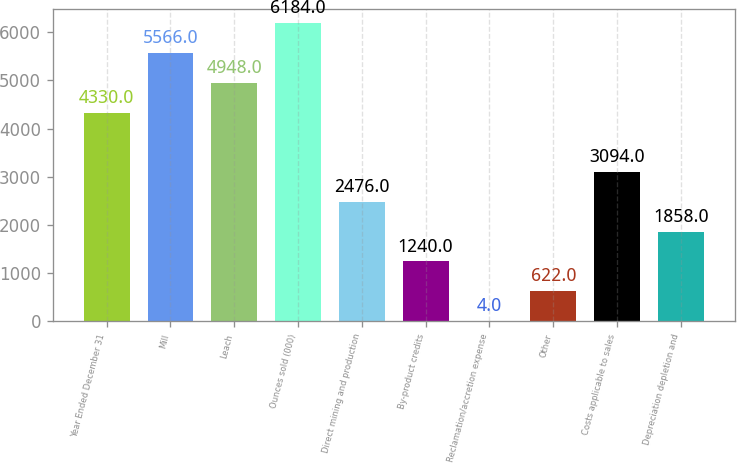<chart> <loc_0><loc_0><loc_500><loc_500><bar_chart><fcel>Year Ended December 31<fcel>Mill<fcel>Leach<fcel>Ounces sold (000)<fcel>Direct mining and production<fcel>By-product credits<fcel>Reclamation/accretion expense<fcel>Other<fcel>Costs applicable to sales<fcel>Depreciation depletion and<nl><fcel>4330<fcel>5566<fcel>4948<fcel>6184<fcel>2476<fcel>1240<fcel>4<fcel>622<fcel>3094<fcel>1858<nl></chart> 